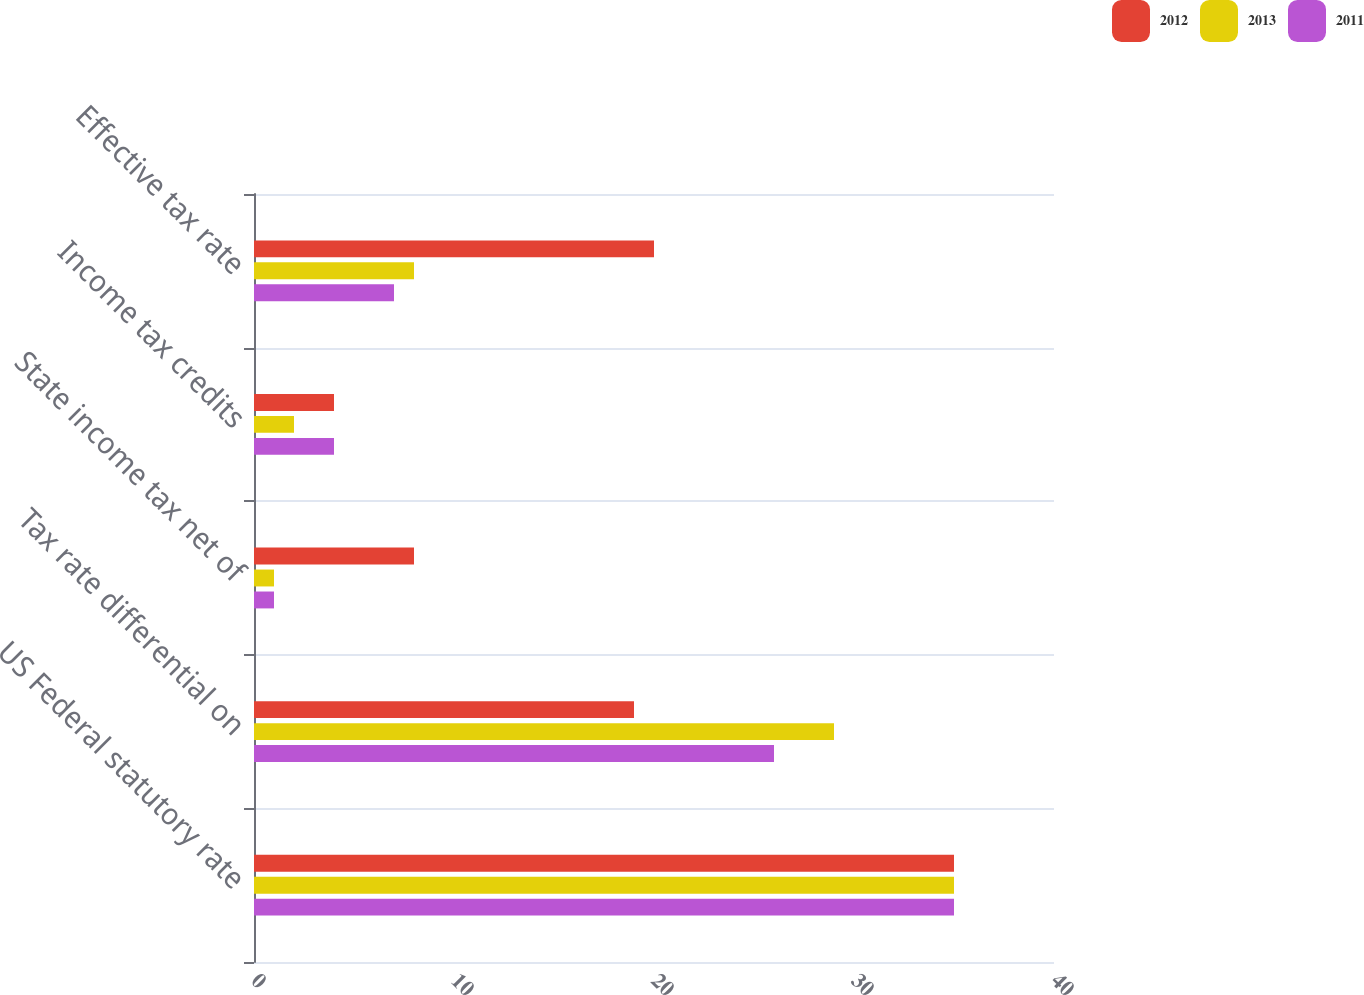Convert chart to OTSL. <chart><loc_0><loc_0><loc_500><loc_500><stacked_bar_chart><ecel><fcel>US Federal statutory rate<fcel>Tax rate differential on<fcel>State income tax net of<fcel>Income tax credits<fcel>Effective tax rate<nl><fcel>2012<fcel>35<fcel>19<fcel>8<fcel>4<fcel>20<nl><fcel>2013<fcel>35<fcel>29<fcel>1<fcel>2<fcel>8<nl><fcel>2011<fcel>35<fcel>26<fcel>1<fcel>4<fcel>7<nl></chart> 